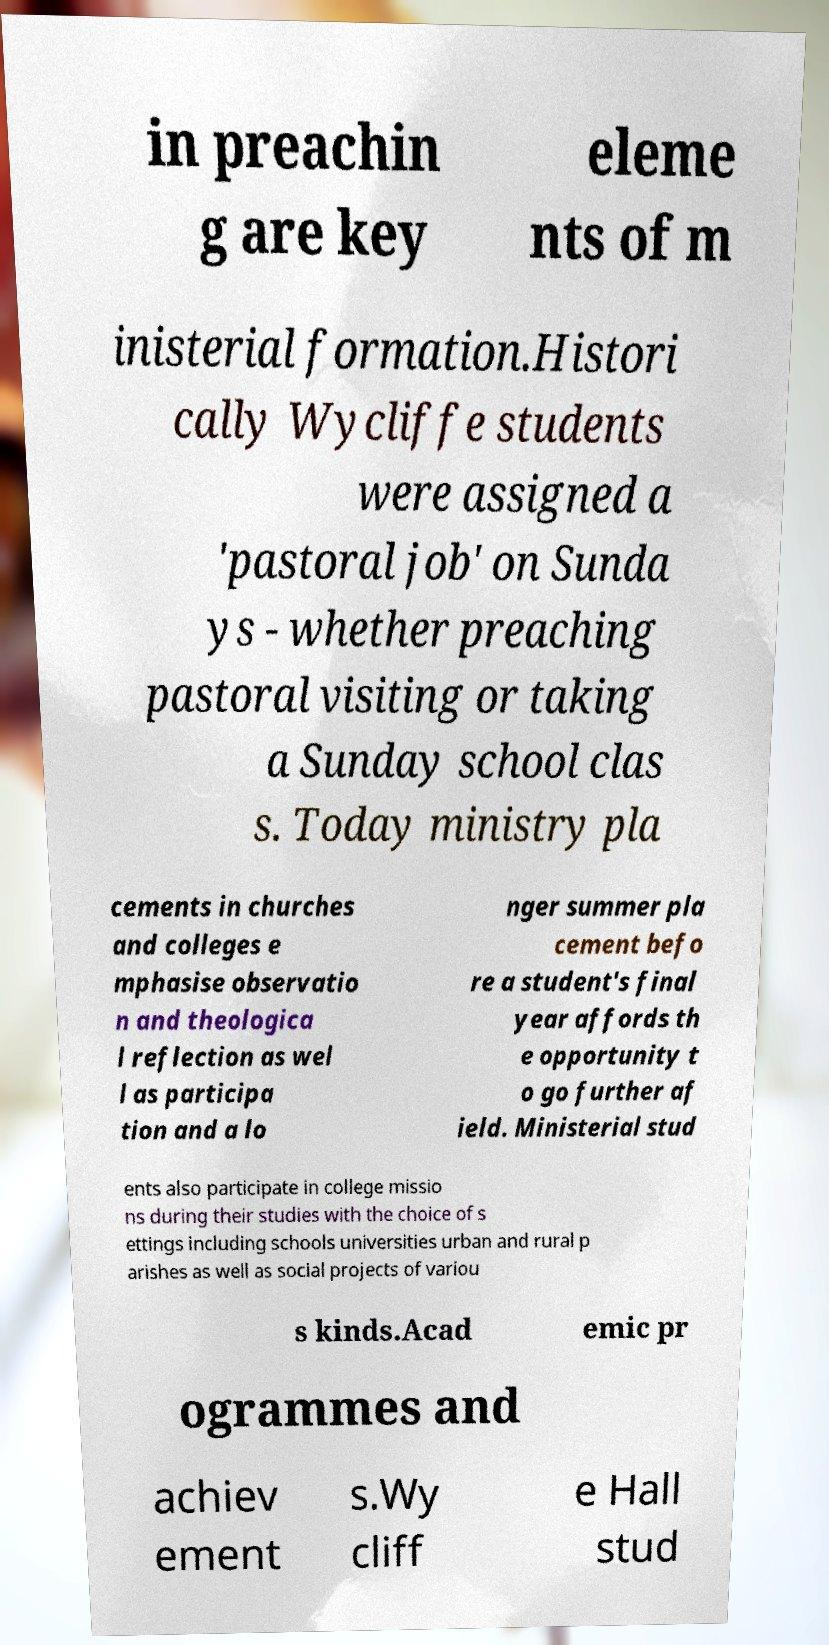Please read and relay the text visible in this image. What does it say? in preachin g are key eleme nts of m inisterial formation.Histori cally Wycliffe students were assigned a 'pastoral job' on Sunda ys - whether preaching pastoral visiting or taking a Sunday school clas s. Today ministry pla cements in churches and colleges e mphasise observatio n and theologica l reflection as wel l as participa tion and a lo nger summer pla cement befo re a student's final year affords th e opportunity t o go further af ield. Ministerial stud ents also participate in college missio ns during their studies with the choice of s ettings including schools universities urban and rural p arishes as well as social projects of variou s kinds.Acad emic pr ogrammes and achiev ement s.Wy cliff e Hall stud 